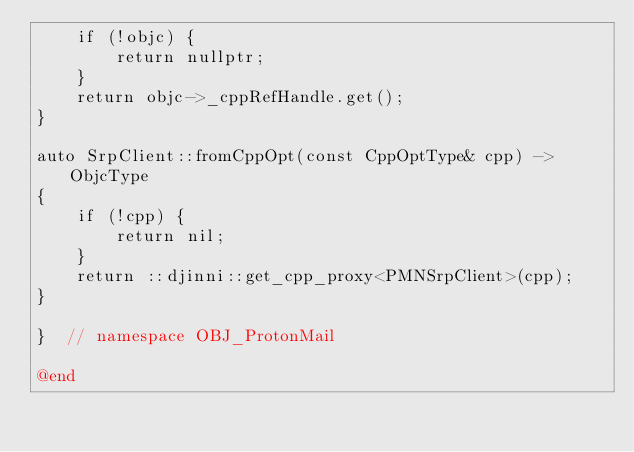Convert code to text. <code><loc_0><loc_0><loc_500><loc_500><_ObjectiveC_>    if (!objc) {
        return nullptr;
    }
    return objc->_cppRefHandle.get();
}

auto SrpClient::fromCppOpt(const CppOptType& cpp) -> ObjcType
{
    if (!cpp) {
        return nil;
    }
    return ::djinni::get_cpp_proxy<PMNSrpClient>(cpp);
}

}  // namespace OBJ_ProtonMail

@end
</code> 